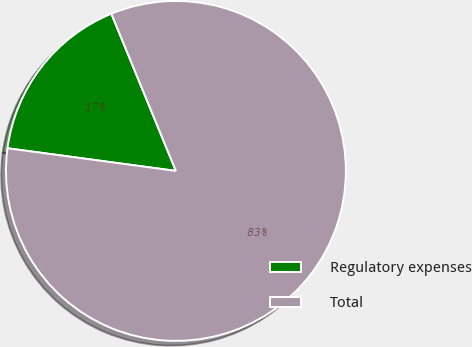Convert chart to OTSL. <chart><loc_0><loc_0><loc_500><loc_500><pie_chart><fcel>Regulatory expenses<fcel>Total<nl><fcel>16.67%<fcel>83.33%<nl></chart> 